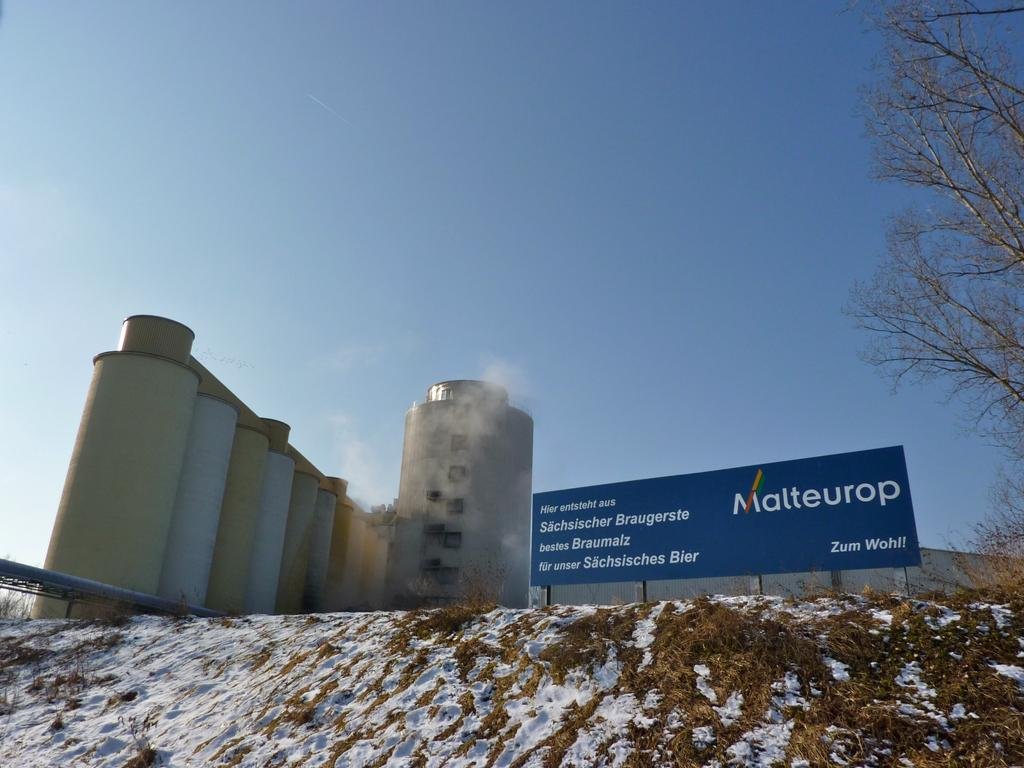<image>
Offer a succinct explanation of the picture presented. A building on a hill shows a sign with the word Malteurop. 